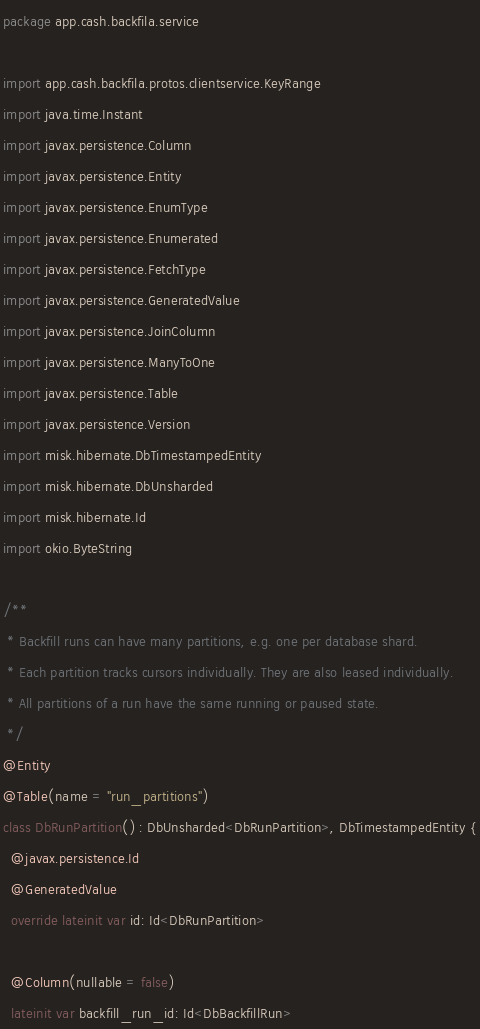<code> <loc_0><loc_0><loc_500><loc_500><_Kotlin_>package app.cash.backfila.service

import app.cash.backfila.protos.clientservice.KeyRange
import java.time.Instant
import javax.persistence.Column
import javax.persistence.Entity
import javax.persistence.EnumType
import javax.persistence.Enumerated
import javax.persistence.FetchType
import javax.persistence.GeneratedValue
import javax.persistence.JoinColumn
import javax.persistence.ManyToOne
import javax.persistence.Table
import javax.persistence.Version
import misk.hibernate.DbTimestampedEntity
import misk.hibernate.DbUnsharded
import misk.hibernate.Id
import okio.ByteString

/**
 * Backfill runs can have many partitions, e.g. one per database shard.
 * Each partition tracks cursors individually. They are also leased individually.
 * All partitions of a run have the same running or paused state.
 */
@Entity
@Table(name = "run_partitions")
class DbRunPartition() : DbUnsharded<DbRunPartition>, DbTimestampedEntity {
  @javax.persistence.Id
  @GeneratedValue
  override lateinit var id: Id<DbRunPartition>

  @Column(nullable = false)
  lateinit var backfill_run_id: Id<DbBackfillRun>
</code> 